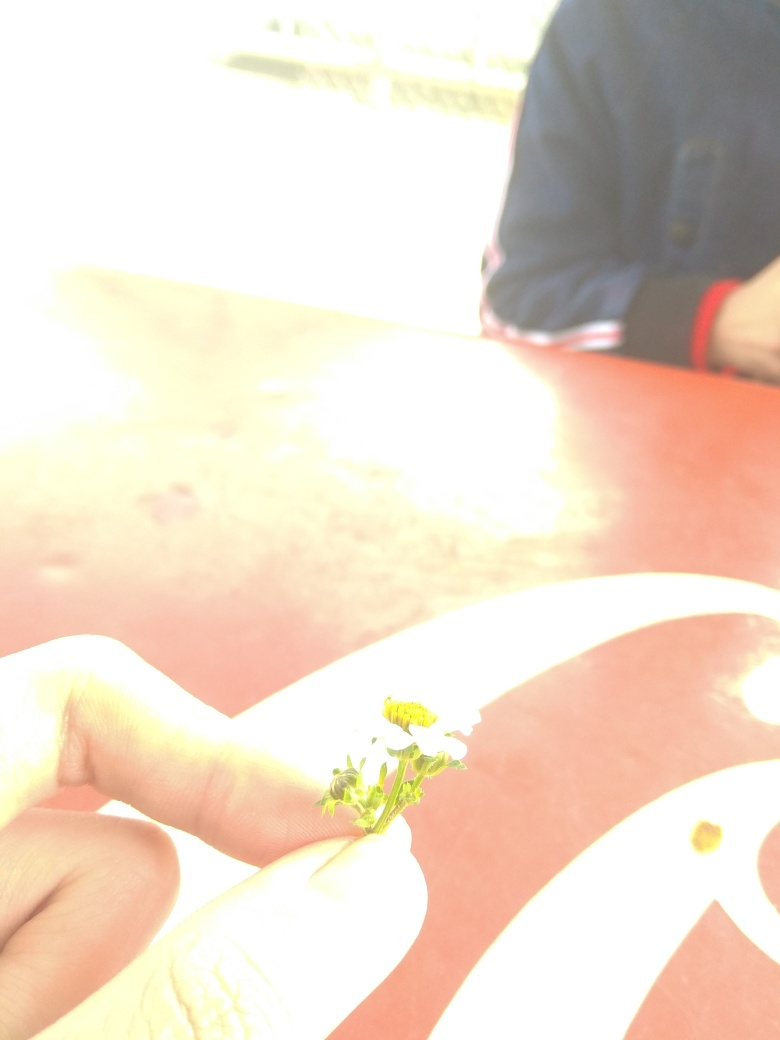Is the composition of this image straight or leveled?
A. Crooked
B. Yes
C. No
Answer with the option's letter from the given choices directly. The question seems to ask whether the composition of the image is level. However, the options provided don't correspond appropriately to a 'yes' or 'no' question format. The correct response to whether an image is level would typically be 'yes' it is level, or 'no' it is not, but the given options don't reflect that understanding. A crooked image would correspond with an answer indicating the image is not level. In this image, since it is challenging to discern levelness due to overexposure and lack of clear horizontal or vertical reference points, a more suitable response may not be feasible without further image details. 